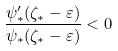Convert formula to latex. <formula><loc_0><loc_0><loc_500><loc_500>\frac { \psi ^ { \prime } _ { * } ( \zeta _ { * } - \varepsilon ) } { \psi _ { * } ( \zeta _ { * } - \varepsilon ) } < 0</formula> 